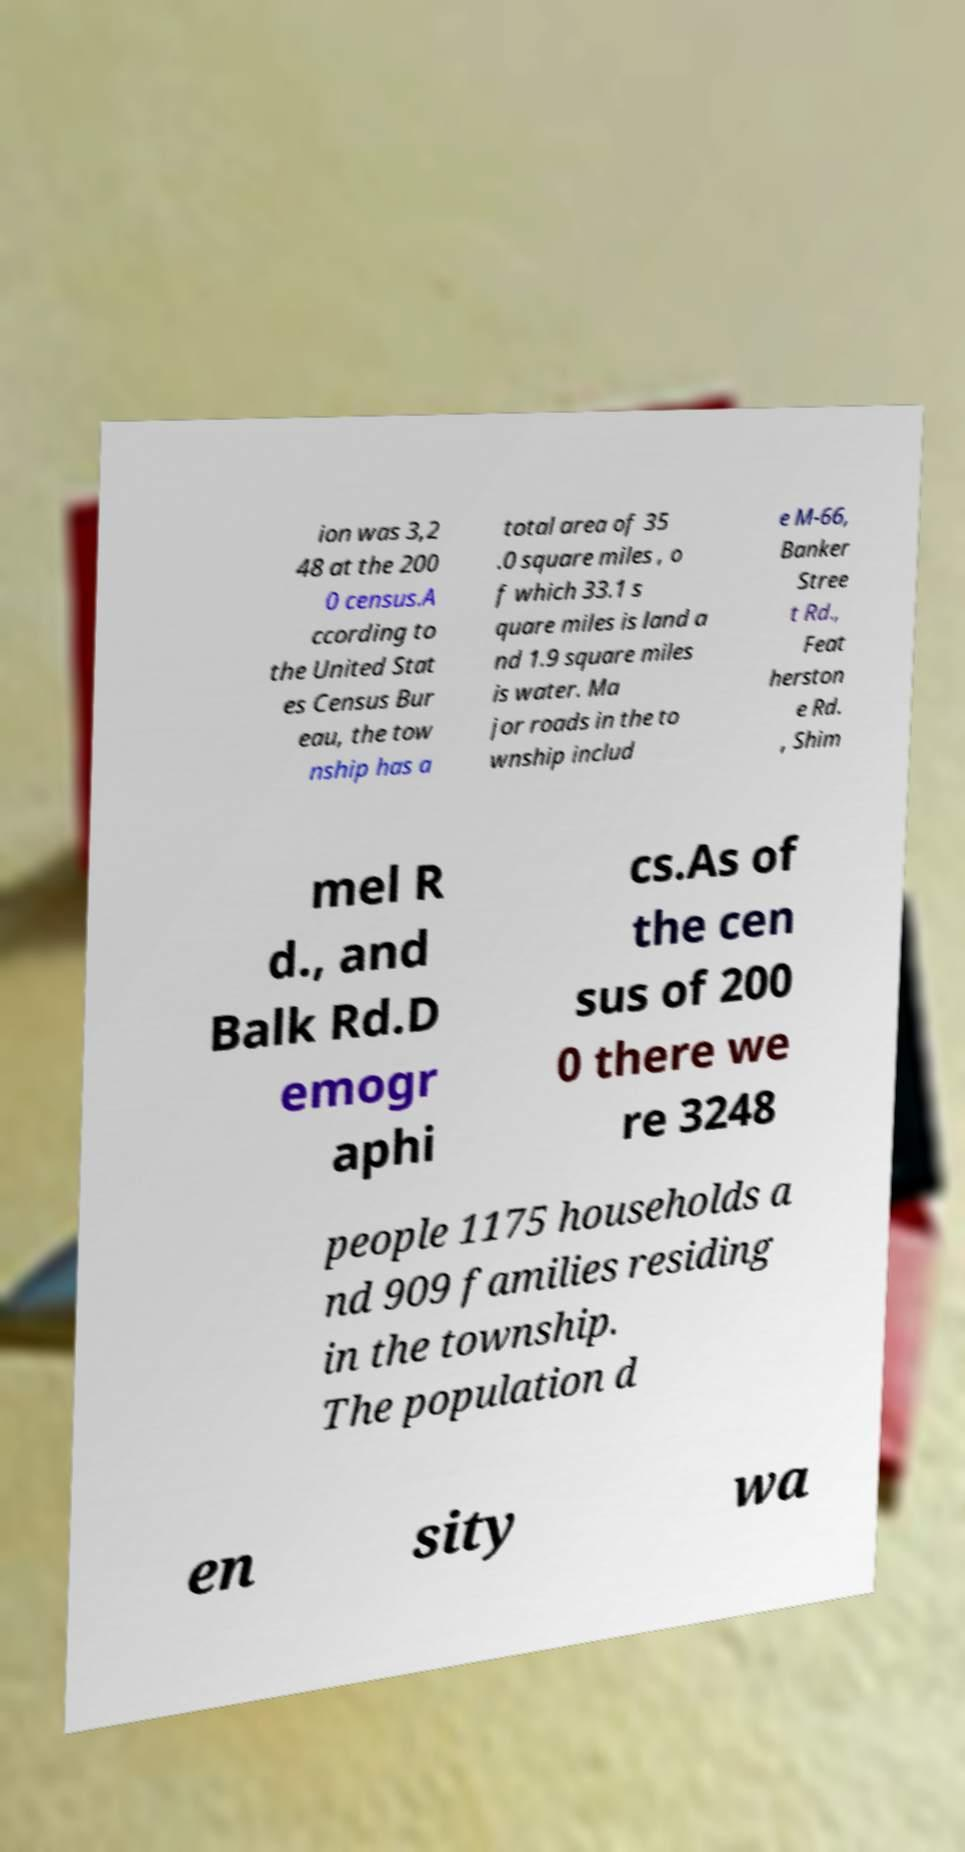Could you assist in decoding the text presented in this image and type it out clearly? ion was 3,2 48 at the 200 0 census.A ccording to the United Stat es Census Bur eau, the tow nship has a total area of 35 .0 square miles , o f which 33.1 s quare miles is land a nd 1.9 square miles is water. Ma jor roads in the to wnship includ e M-66, Banker Stree t Rd., Feat herston e Rd. , Shim mel R d., and Balk Rd.D emogr aphi cs.As of the cen sus of 200 0 there we re 3248 people 1175 households a nd 909 families residing in the township. The population d en sity wa 